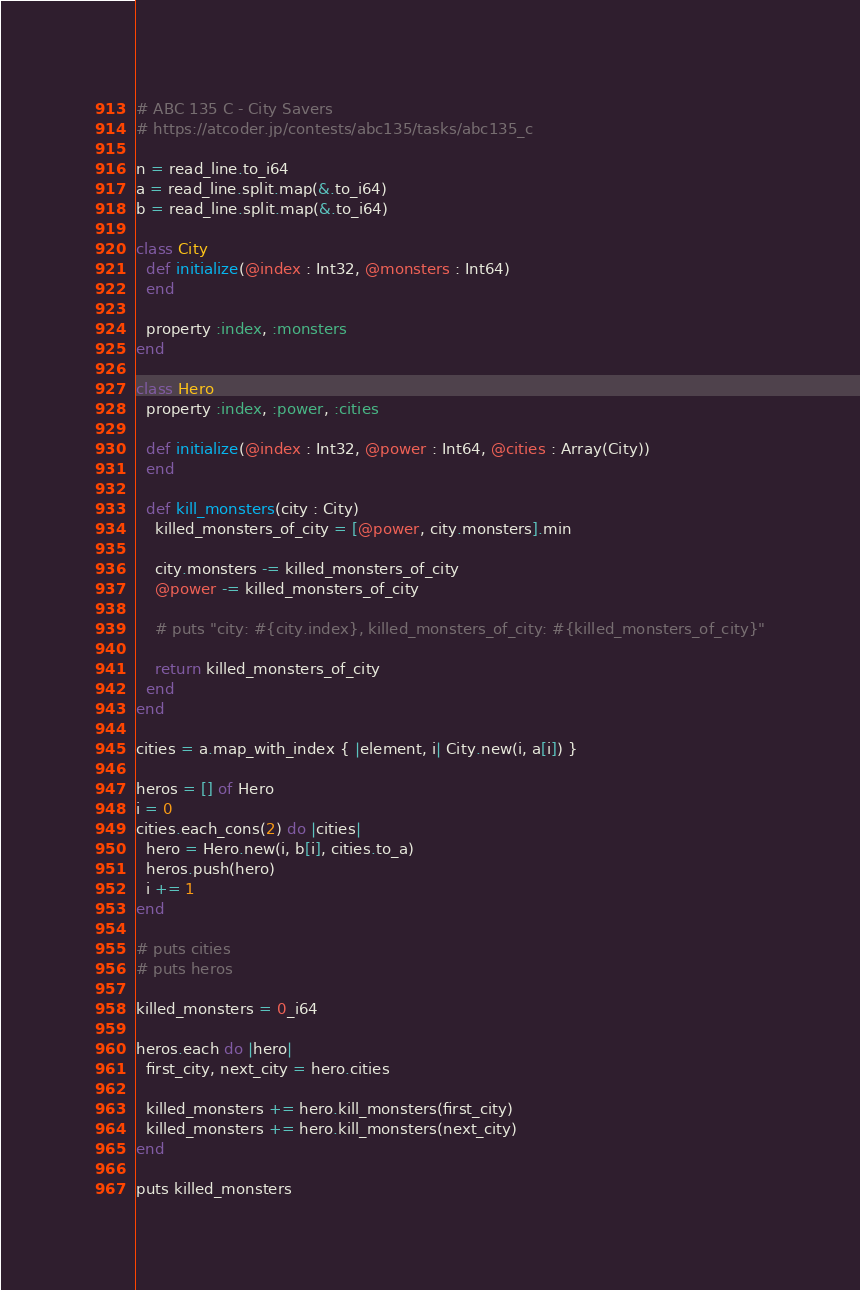Convert code to text. <code><loc_0><loc_0><loc_500><loc_500><_Crystal_># ABC 135 C - City Savers
# https://atcoder.jp/contests/abc135/tasks/abc135_c

n = read_line.to_i64
a = read_line.split.map(&.to_i64)
b = read_line.split.map(&.to_i64)

class City
  def initialize(@index : Int32, @monsters : Int64)
  end

  property :index, :monsters
end

class Hero
  property :index, :power, :cities

  def initialize(@index : Int32, @power : Int64, @cities : Array(City))
  end

  def kill_monsters(city : City)
    killed_monsters_of_city = [@power, city.monsters].min

    city.monsters -= killed_monsters_of_city
    @power -= killed_monsters_of_city

    # puts "city: #{city.index}, killed_monsters_of_city: #{killed_monsters_of_city}"

    return killed_monsters_of_city
  end
end

cities = a.map_with_index { |element, i| City.new(i, a[i]) }

heros = [] of Hero
i = 0
cities.each_cons(2) do |cities|
  hero = Hero.new(i, b[i], cities.to_a)
  heros.push(hero)
  i += 1
end

# puts cities
# puts heros

killed_monsters = 0_i64

heros.each do |hero|
  first_city, next_city = hero.cities

  killed_monsters += hero.kill_monsters(first_city)
  killed_monsters += hero.kill_monsters(next_city)
end

puts killed_monsters
</code> 